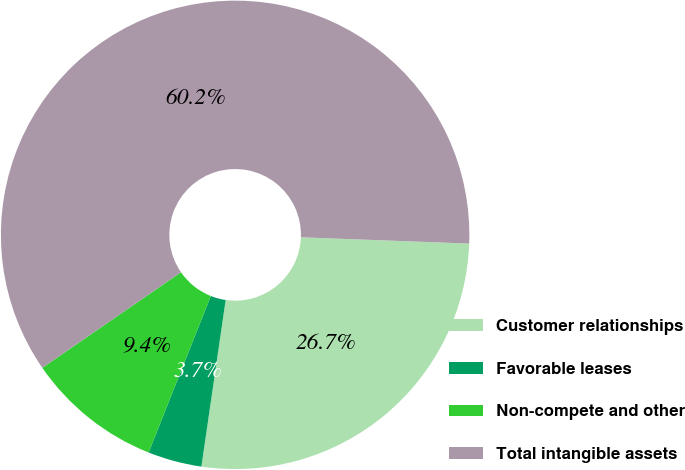<chart> <loc_0><loc_0><loc_500><loc_500><pie_chart><fcel>Customer relationships<fcel>Favorable leases<fcel>Non-compete and other<fcel>Total intangible assets<nl><fcel>26.71%<fcel>3.72%<fcel>9.37%<fcel>60.2%<nl></chart> 